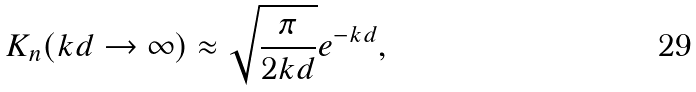Convert formula to latex. <formula><loc_0><loc_0><loc_500><loc_500>K _ { n } ( k d \rightarrow \infty ) \approx \sqrt { \frac { \pi } { 2 k d } } e ^ { - k d } ,</formula> 